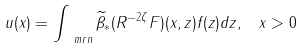<formula> <loc_0><loc_0><loc_500><loc_500>u ( x ) = \int _ { \ m r n } { \widetilde { \beta } } _ { * } ( R ^ { - 2 \zeta } F ) ( x , z ) f ( z ) d z , \, \ x > 0</formula> 